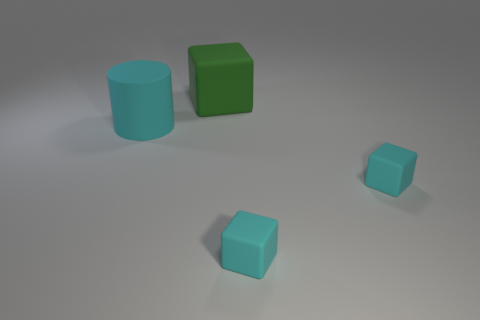How many other objects are the same color as the big rubber cube?
Give a very brief answer. 0. What number of things are either matte objects that are right of the cyan matte cylinder or cyan things that are to the left of the large green rubber object?
Offer a terse response. 4. Is the number of tiny brown things less than the number of small blocks?
Ensure brevity in your answer.  Yes. There is a green matte cube; is its size the same as the object that is to the left of the green rubber thing?
Your answer should be compact. Yes. How many shiny things are large cylinders or big green objects?
Provide a succinct answer. 0. Is the number of green cubes greater than the number of cyan matte cubes?
Ensure brevity in your answer.  No. There is a large matte object that is behind the large rubber cylinder in front of the large block; what is its shape?
Your answer should be very brief. Cube. Is there a big thing left of the matte object that is behind the cyan matte thing on the left side of the green object?
Your answer should be very brief. Yes. What color is the matte object that is the same size as the green rubber block?
Keep it short and to the point. Cyan. What size is the rubber thing behind the cyan matte object that is to the left of the large block?
Your response must be concise. Large. 